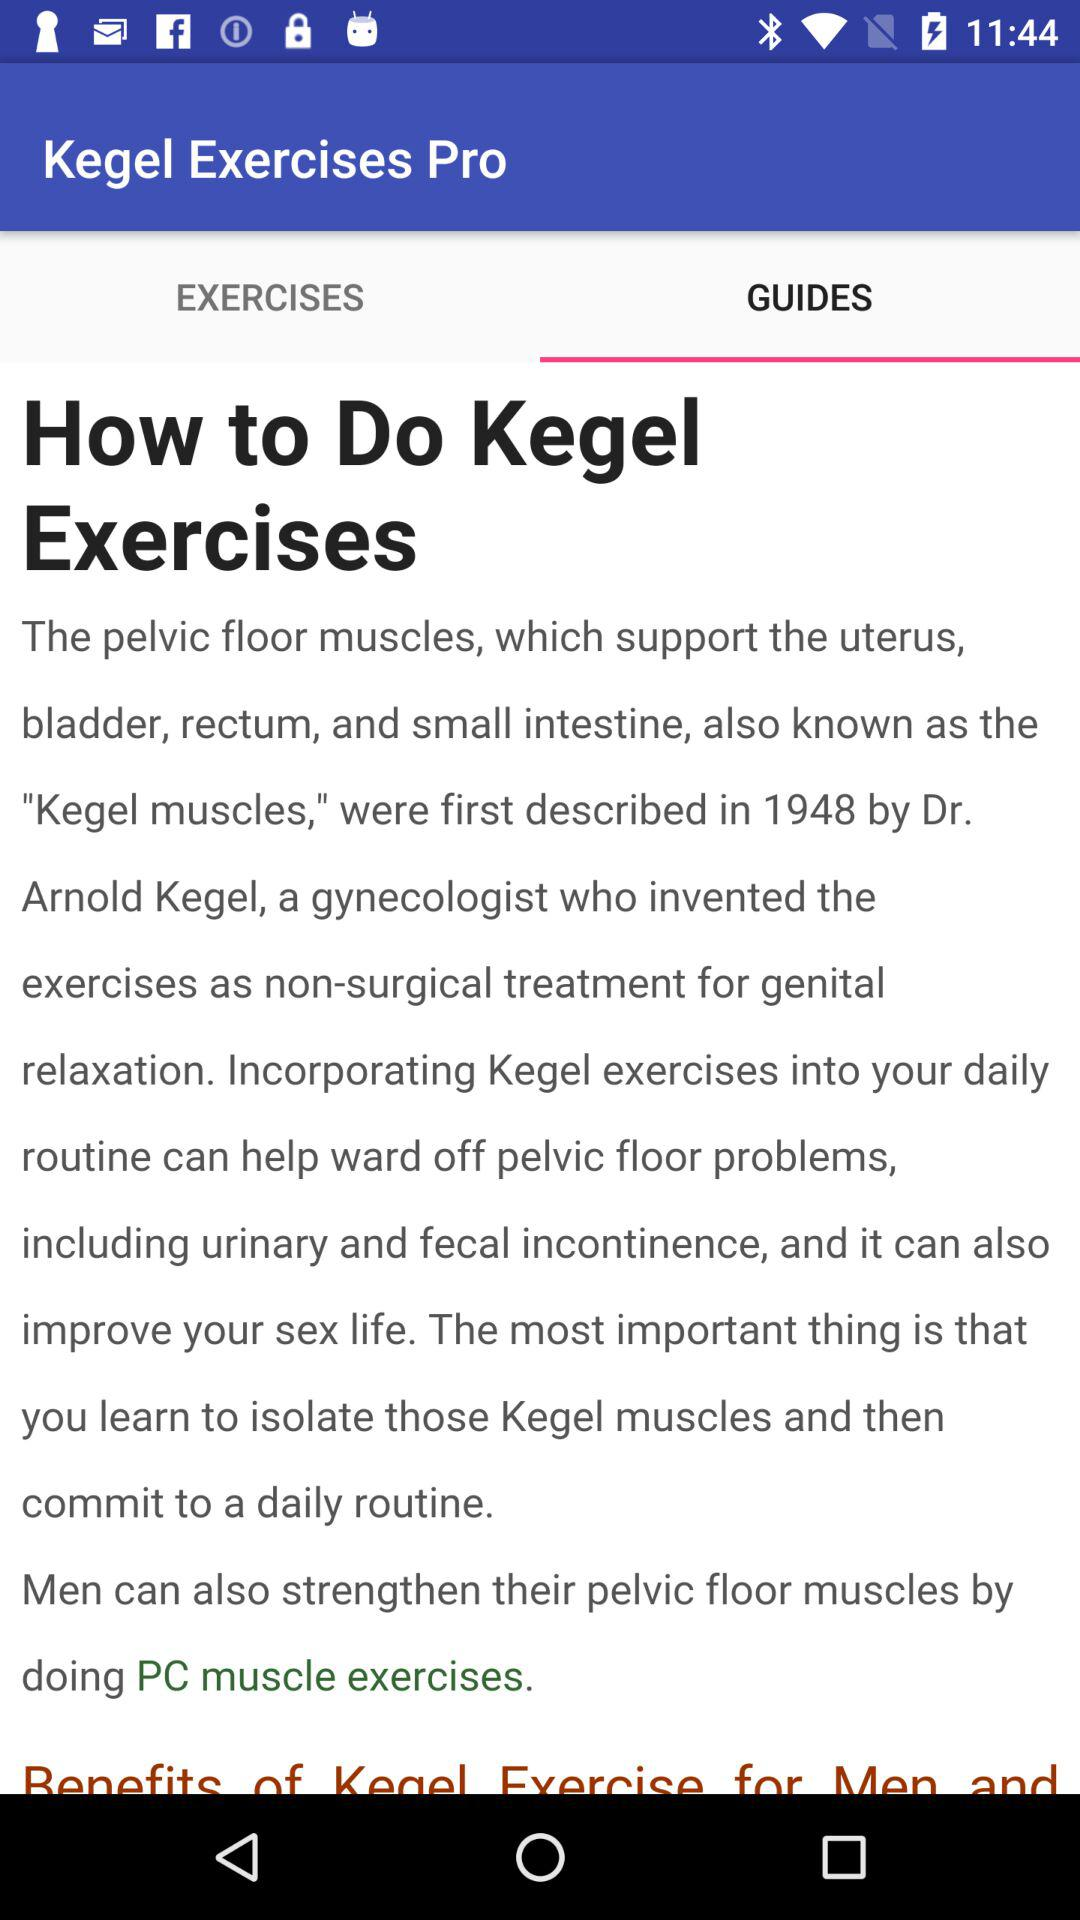What is the selected tab? The selected tab is "GUIDES". 